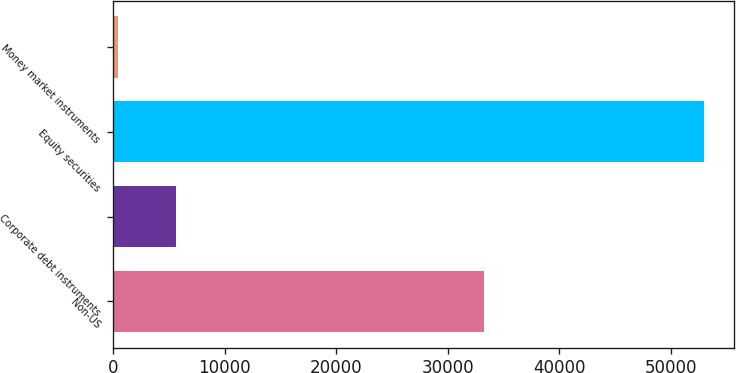Convert chart. <chart><loc_0><loc_0><loc_500><loc_500><bar_chart><fcel>Non-US<fcel>Corporate debt instruments<fcel>Equity securities<fcel>Money market instruments<nl><fcel>33231<fcel>5657.1<fcel>52989<fcel>398<nl></chart> 